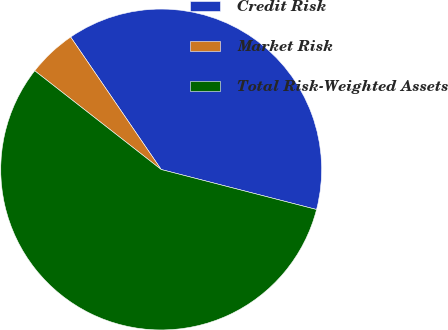Convert chart to OTSL. <chart><loc_0><loc_0><loc_500><loc_500><pie_chart><fcel>Credit Risk<fcel>Market Risk<fcel>Total Risk-Weighted Assets<nl><fcel>38.55%<fcel>4.91%<fcel>56.54%<nl></chart> 